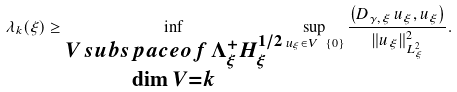<formula> <loc_0><loc_0><loc_500><loc_500>\lambda _ { k } ( \xi ) \geq \inf _ { \substack { V \, s u b s p a c e o f \, \Lambda _ { \xi } ^ { + } H _ { \xi } ^ { 1 / 2 } \\ \dim V = k } } \sup _ { u _ { \xi } \in V \ \{ 0 \} } \frac { \left ( D _ { \gamma , \xi } \, u _ { \xi } , u _ { \xi } \right ) } { \| u _ { \xi } \| _ { L ^ { 2 } _ { \xi } } ^ { 2 } } .</formula> 